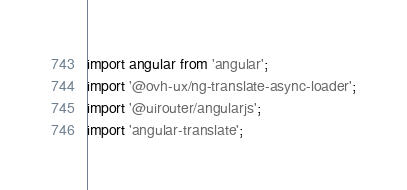Convert code to text. <code><loc_0><loc_0><loc_500><loc_500><_JavaScript_>import angular from 'angular';
import '@ovh-ux/ng-translate-async-loader';
import '@uirouter/angularjs';
import 'angular-translate';</code> 